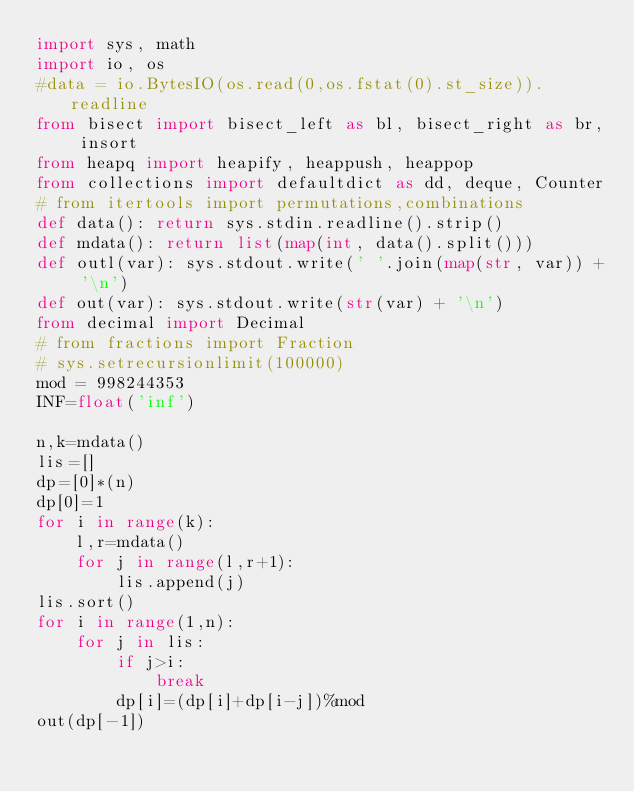Convert code to text. <code><loc_0><loc_0><loc_500><loc_500><_Python_>import sys, math
import io, os
#data = io.BytesIO(os.read(0,os.fstat(0).st_size)).readline
from bisect import bisect_left as bl, bisect_right as br, insort
from heapq import heapify, heappush, heappop
from collections import defaultdict as dd, deque, Counter
# from itertools import permutations,combinations
def data(): return sys.stdin.readline().strip()
def mdata(): return list(map(int, data().split()))
def outl(var): sys.stdout.write(' '.join(map(str, var)) + '\n')
def out(var): sys.stdout.write(str(var) + '\n')
from decimal import Decimal
# from fractions import Fraction
# sys.setrecursionlimit(100000)
mod = 998244353
INF=float('inf')
 
n,k=mdata()
lis=[]
dp=[0]*(n)
dp[0]=1
for i in range(k):
    l,r=mdata()
    for j in range(l,r+1):
        lis.append(j)
lis.sort()
for i in range(1,n):
    for j in lis:
        if j>i:
            break
        dp[i]=(dp[i]+dp[i-j])%mod
out(dp[-1])</code> 